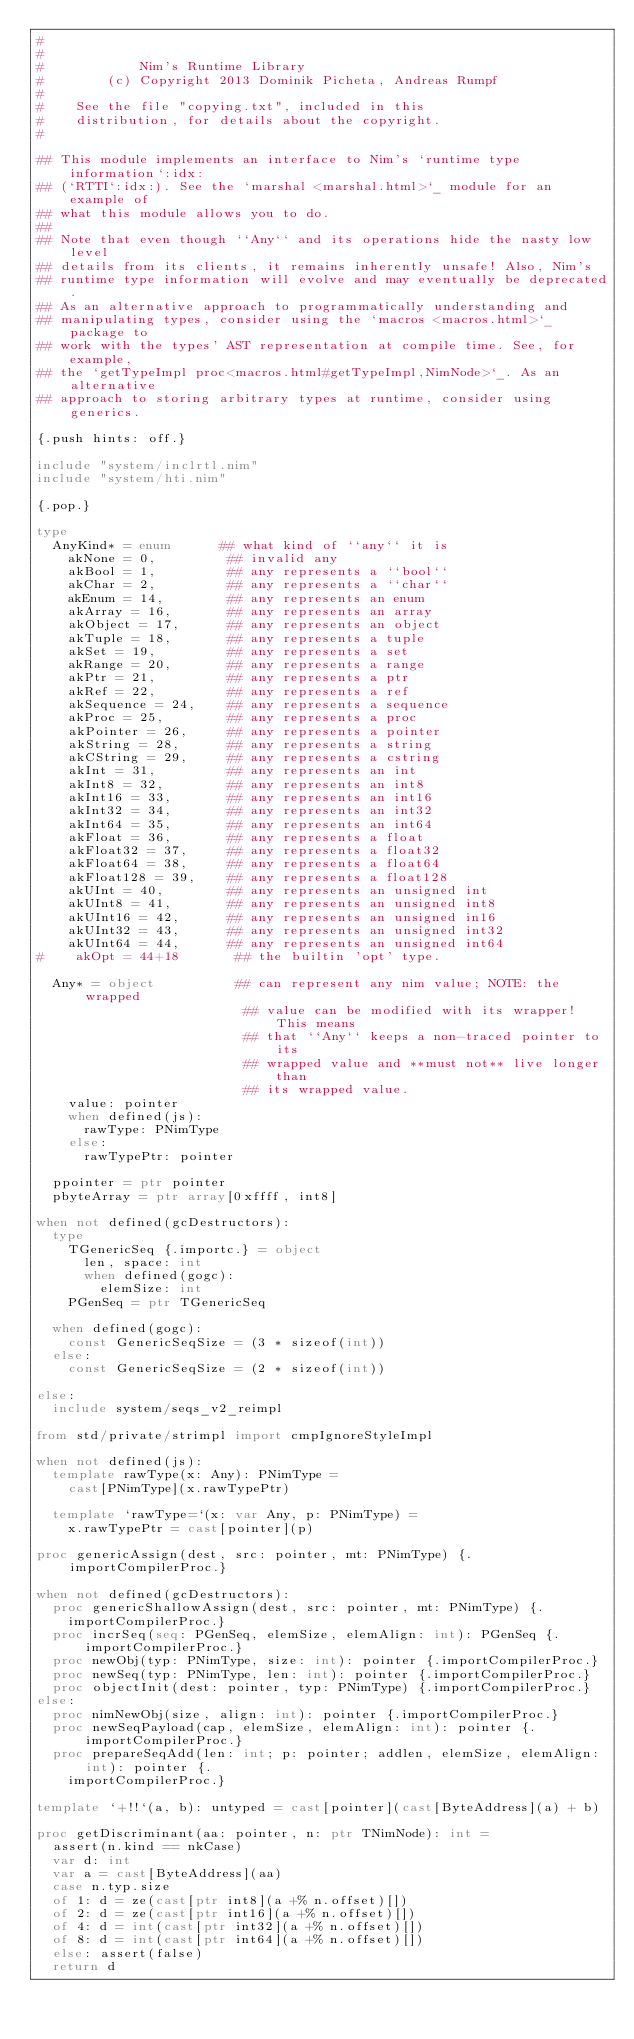Convert code to text. <code><loc_0><loc_0><loc_500><loc_500><_Nim_>#
#
#            Nim's Runtime Library
#        (c) Copyright 2013 Dominik Picheta, Andreas Rumpf
#
#    See the file "copying.txt", included in this
#    distribution, for details about the copyright.
#

## This module implements an interface to Nim's `runtime type information`:idx:
## (`RTTI`:idx:). See the `marshal <marshal.html>`_ module for an example of
## what this module allows you to do.
##
## Note that even though ``Any`` and its operations hide the nasty low level
## details from its clients, it remains inherently unsafe! Also, Nim's
## runtime type information will evolve and may eventually be deprecated.
## As an alternative approach to programmatically understanding and
## manipulating types, consider using the `macros <macros.html>`_ package to
## work with the types' AST representation at compile time. See, for example,
## the `getTypeImpl proc<macros.html#getTypeImpl,NimNode>`_. As an alternative
## approach to storing arbitrary types at runtime, consider using generics.

{.push hints: off.}

include "system/inclrtl.nim"
include "system/hti.nim"

{.pop.}

type
  AnyKind* = enum      ## what kind of ``any`` it is
    akNone = 0,         ## invalid any
    akBool = 1,         ## any represents a ``bool``
    akChar = 2,         ## any represents a ``char``
    akEnum = 14,        ## any represents an enum
    akArray = 16,       ## any represents an array
    akObject = 17,      ## any represents an object
    akTuple = 18,       ## any represents a tuple
    akSet = 19,         ## any represents a set
    akRange = 20,       ## any represents a range
    akPtr = 21,         ## any represents a ptr
    akRef = 22,         ## any represents a ref
    akSequence = 24,    ## any represents a sequence
    akProc = 25,        ## any represents a proc
    akPointer = 26,     ## any represents a pointer
    akString = 28,      ## any represents a string
    akCString = 29,     ## any represents a cstring
    akInt = 31,         ## any represents an int
    akInt8 = 32,        ## any represents an int8
    akInt16 = 33,       ## any represents an int16
    akInt32 = 34,       ## any represents an int32
    akInt64 = 35,       ## any represents an int64
    akFloat = 36,       ## any represents a float
    akFloat32 = 37,     ## any represents a float32
    akFloat64 = 38,     ## any represents a float64
    akFloat128 = 39,    ## any represents a float128
    akUInt = 40,        ## any represents an unsigned int
    akUInt8 = 41,       ## any represents an unsigned int8
    akUInt16 = 42,      ## any represents an unsigned in16
    akUInt32 = 43,      ## any represents an unsigned int32
    akUInt64 = 44,      ## any represents an unsigned int64
#    akOpt = 44+18       ## the builtin 'opt' type.

  Any* = object          ## can represent any nim value; NOTE: the wrapped
                          ## value can be modified with its wrapper! This means
                          ## that ``Any`` keeps a non-traced pointer to its
                          ## wrapped value and **must not** live longer than
                          ## its wrapped value.
    value: pointer
    when defined(js):
      rawType: PNimType
    else:
      rawTypePtr: pointer

  ppointer = ptr pointer
  pbyteArray = ptr array[0xffff, int8]

when not defined(gcDestructors):
  type
    TGenericSeq {.importc.} = object
      len, space: int
      when defined(gogc):
        elemSize: int
    PGenSeq = ptr TGenericSeq

  when defined(gogc):
    const GenericSeqSize = (3 * sizeof(int))
  else:
    const GenericSeqSize = (2 * sizeof(int))

else:
  include system/seqs_v2_reimpl

from std/private/strimpl import cmpIgnoreStyleImpl

when not defined(js):
  template rawType(x: Any): PNimType =
    cast[PNimType](x.rawTypePtr)

  template `rawType=`(x: var Any, p: PNimType) =
    x.rawTypePtr = cast[pointer](p)

proc genericAssign(dest, src: pointer, mt: PNimType) {.importCompilerProc.}

when not defined(gcDestructors):
  proc genericShallowAssign(dest, src: pointer, mt: PNimType) {.
    importCompilerProc.}
  proc incrSeq(seq: PGenSeq, elemSize, elemAlign: int): PGenSeq {.importCompilerProc.}
  proc newObj(typ: PNimType, size: int): pointer {.importCompilerProc.}
  proc newSeq(typ: PNimType, len: int): pointer {.importCompilerProc.}
  proc objectInit(dest: pointer, typ: PNimType) {.importCompilerProc.}
else:
  proc nimNewObj(size, align: int): pointer {.importCompilerProc.}
  proc newSeqPayload(cap, elemSize, elemAlign: int): pointer {.importCompilerProc.}
  proc prepareSeqAdd(len: int; p: pointer; addlen, elemSize, elemAlign: int): pointer {.
    importCompilerProc.}

template `+!!`(a, b): untyped = cast[pointer](cast[ByteAddress](a) + b)

proc getDiscriminant(aa: pointer, n: ptr TNimNode): int =
  assert(n.kind == nkCase)
  var d: int
  var a = cast[ByteAddress](aa)
  case n.typ.size
  of 1: d = ze(cast[ptr int8](a +% n.offset)[])
  of 2: d = ze(cast[ptr int16](a +% n.offset)[])
  of 4: d = int(cast[ptr int32](a +% n.offset)[])
  of 8: d = int(cast[ptr int64](a +% n.offset)[])
  else: assert(false)
  return d
</code> 